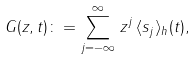<formula> <loc_0><loc_0><loc_500><loc_500>G ( z , t ) \colon = \sum _ { j = - \infty } ^ { \infty } \, z ^ { j } \, \langle s _ { j } \rangle _ { h } ( t ) ,</formula> 